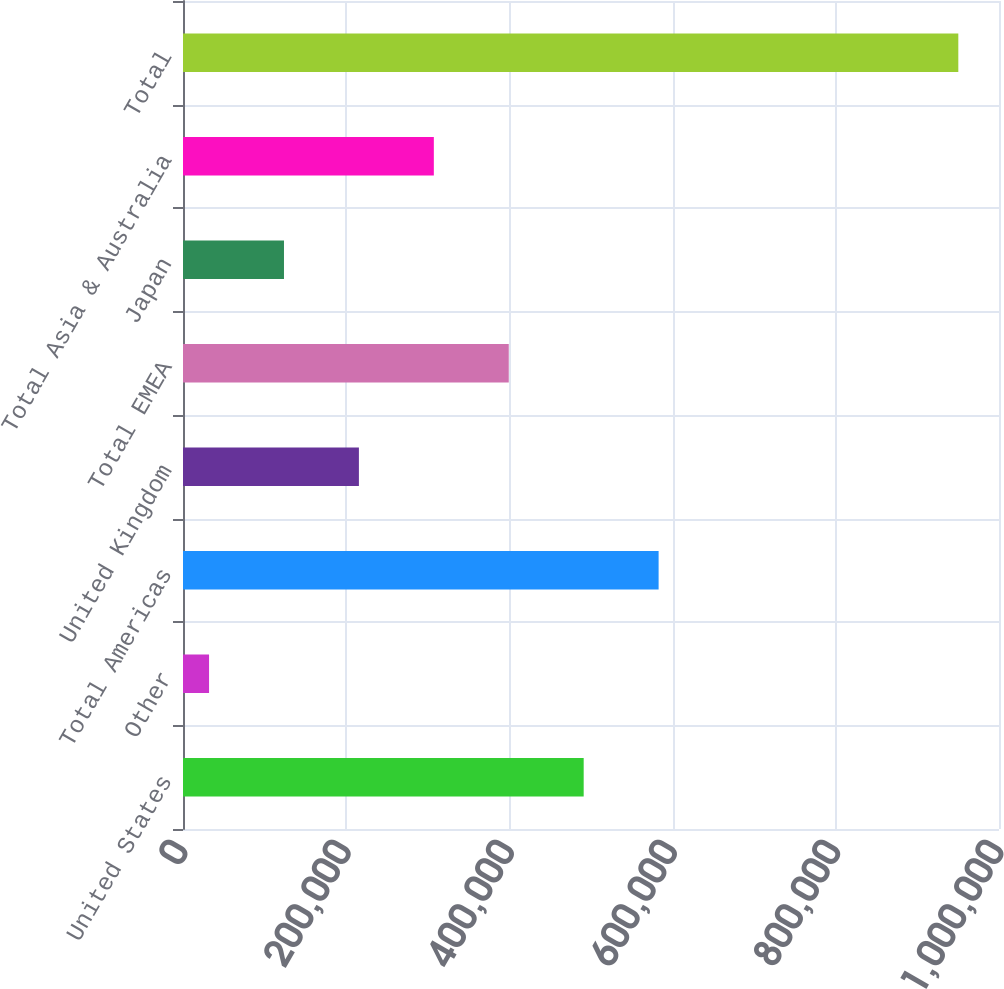<chart> <loc_0><loc_0><loc_500><loc_500><bar_chart><fcel>United States<fcel>Other<fcel>Total Americas<fcel>United Kingdom<fcel>Total EMEA<fcel>Japan<fcel>Total Asia & Australia<fcel>Total<nl><fcel>491035<fcel>31929<fcel>582856<fcel>215571<fcel>399214<fcel>123750<fcel>307393<fcel>950141<nl></chart> 